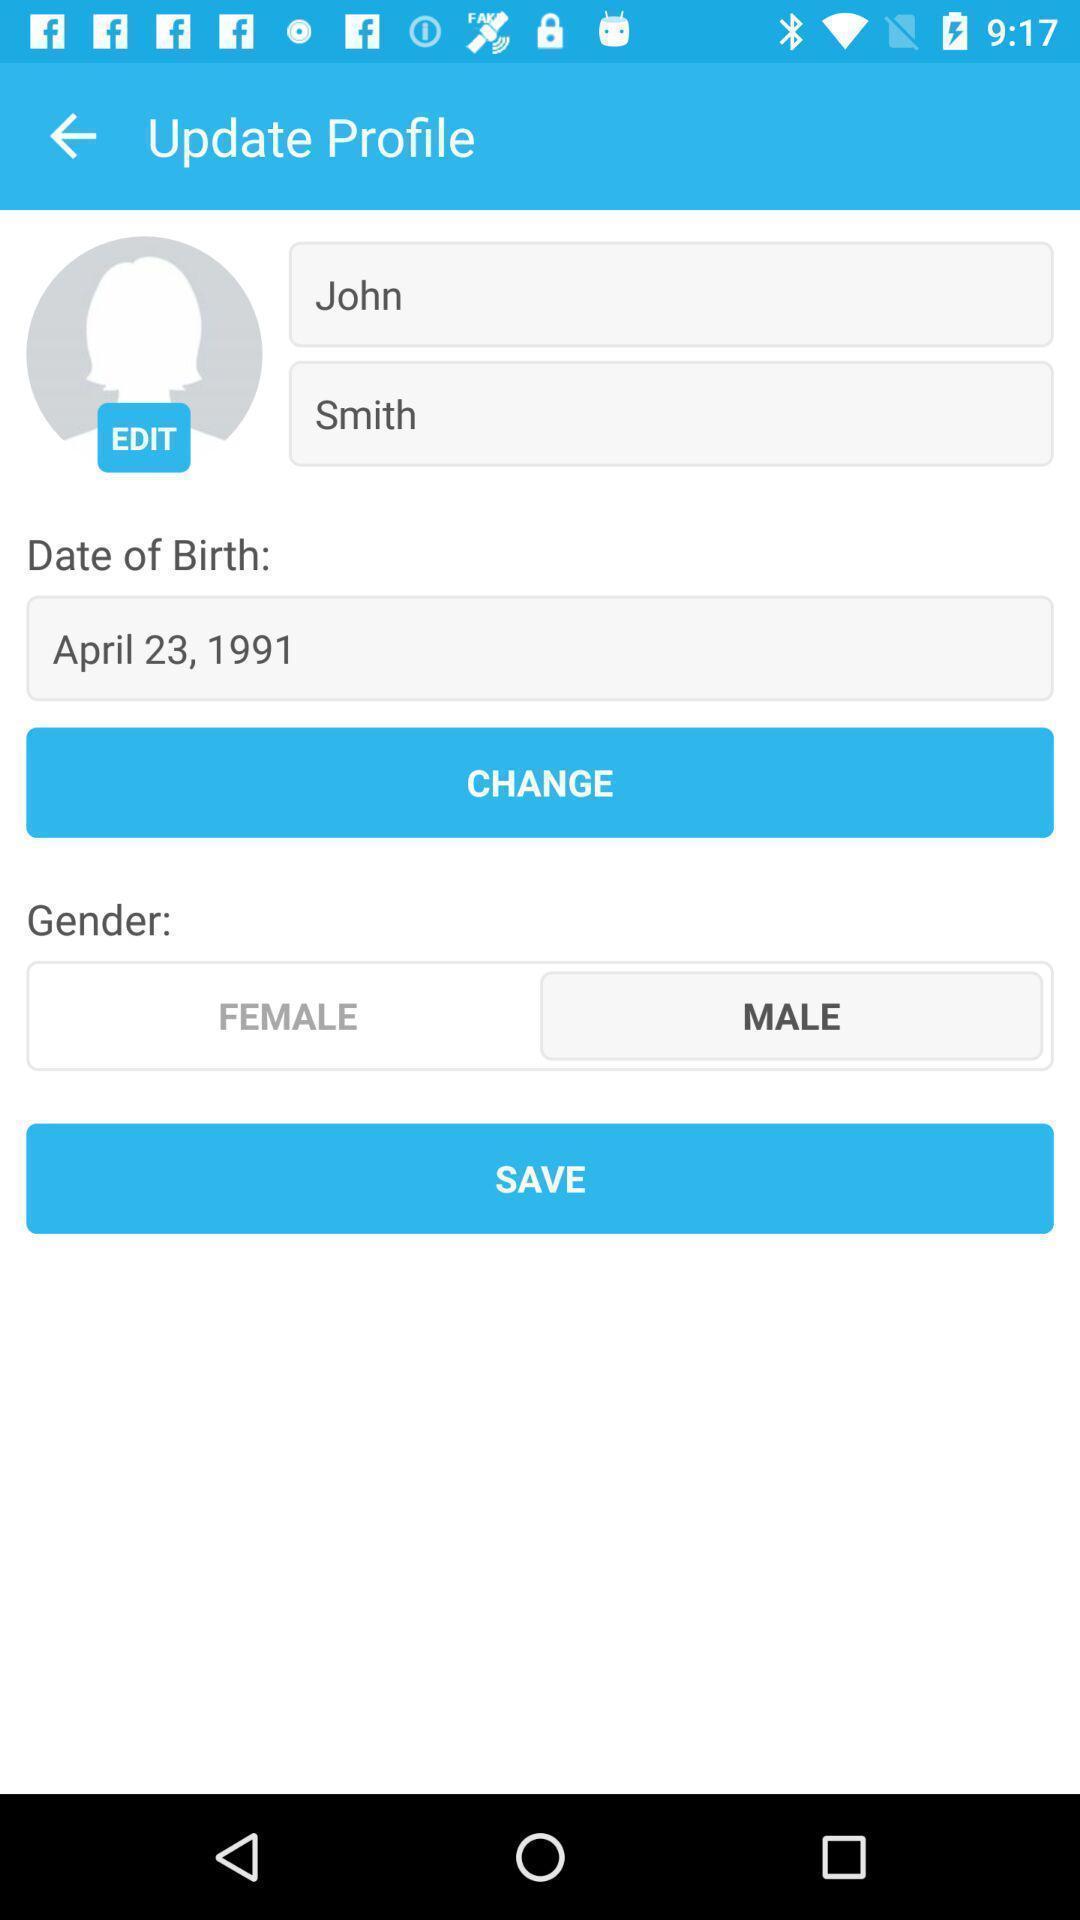Give me a narrative description of this picture. Screen shows profile page in the application. 